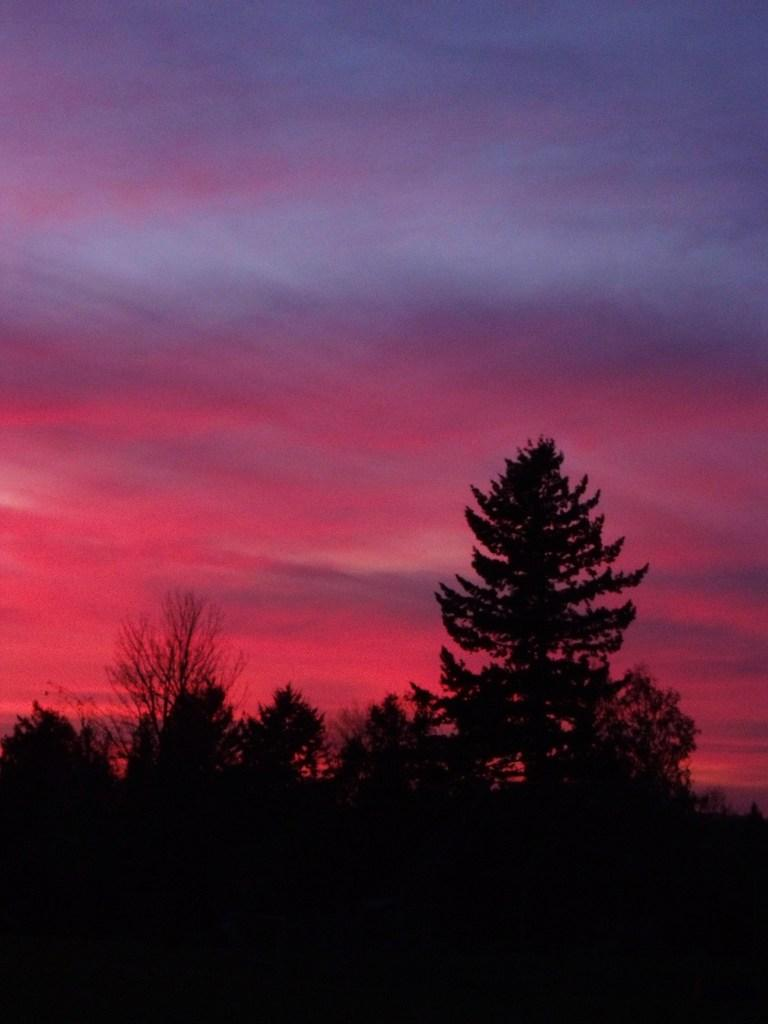What is located in the middle of the image? There are trees in the middle of the image. What is visible in the image besides the trees? The sky is visible in the image. What colors can be seen in the sky? The sky is blue and pink in color. What is the color of the bottom part of the image? The bottom part of the image is black in color. Can you see the father and the sea in the image? There is no father or sea present in the image. Is there a can visible in the image? There is no can present in the image. 